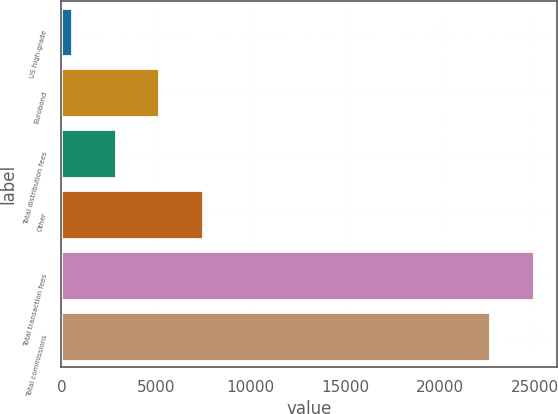<chart> <loc_0><loc_0><loc_500><loc_500><bar_chart><fcel>US high-grade<fcel>Eurobond<fcel>Total distribution fees<fcel>Other<fcel>Total transaction fees<fcel>Total commissions<nl><fcel>544<fcel>5170.6<fcel>2857.3<fcel>7483.9<fcel>24917.3<fcel>22604<nl></chart> 